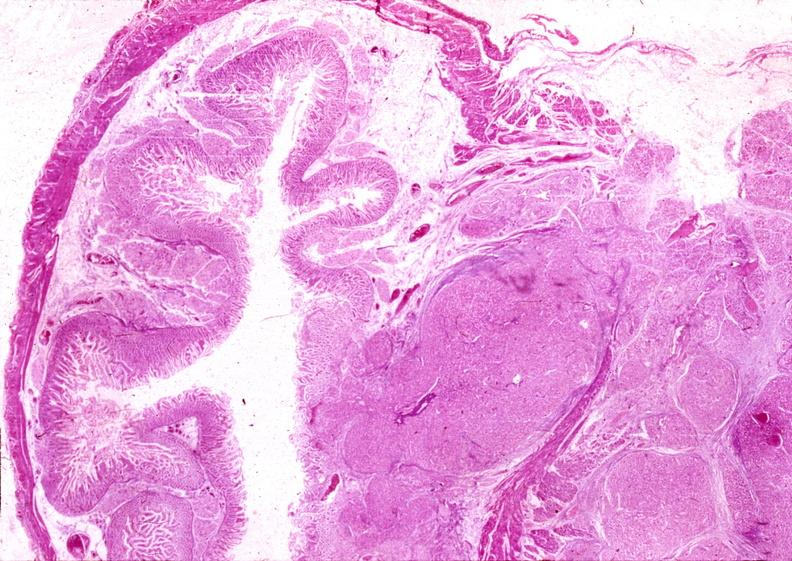s hyalin mass in pituitary which is amyloid there are several slides from this case in this file 23 yowf amyloid limited to brain present?
Answer the question using a single word or phrase. No 